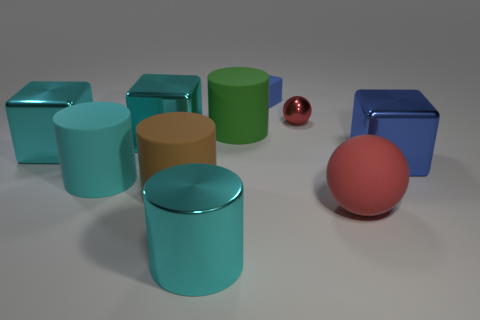Can you describe the colors of the cylinders and tell me how many there are? There are six cylinders in the image with varying colors: teal, blue, green, cyan, olive, and gray. 